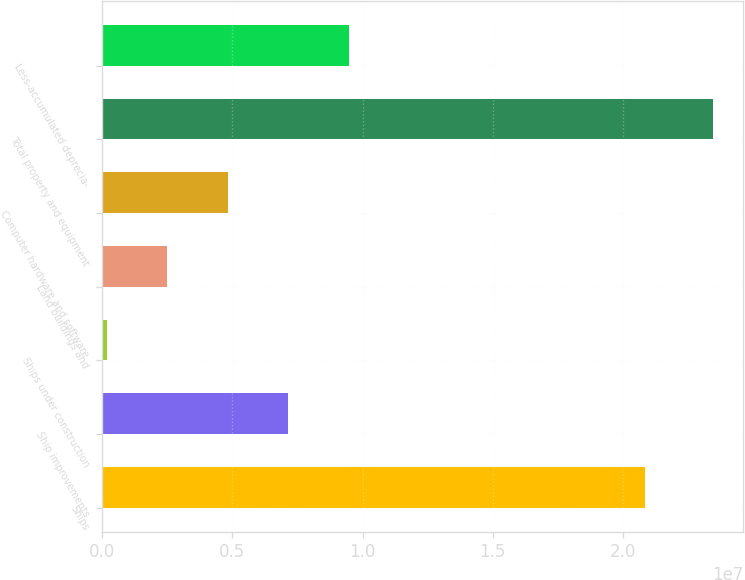Convert chart. <chart><loc_0><loc_0><loc_500><loc_500><bar_chart><fcel>Ships<fcel>Ship improvements<fcel>Ships under construction<fcel>Land buildings and<fcel>Computer hardware and software<fcel>Total property and equipment<fcel>Less-accumulated deprecia-<nl><fcel>2.08556e+07<fcel>7.1513e+06<fcel>169274<fcel>2.49662e+06<fcel>4.82396e+06<fcel>2.34427e+07<fcel>9.47865e+06<nl></chart> 